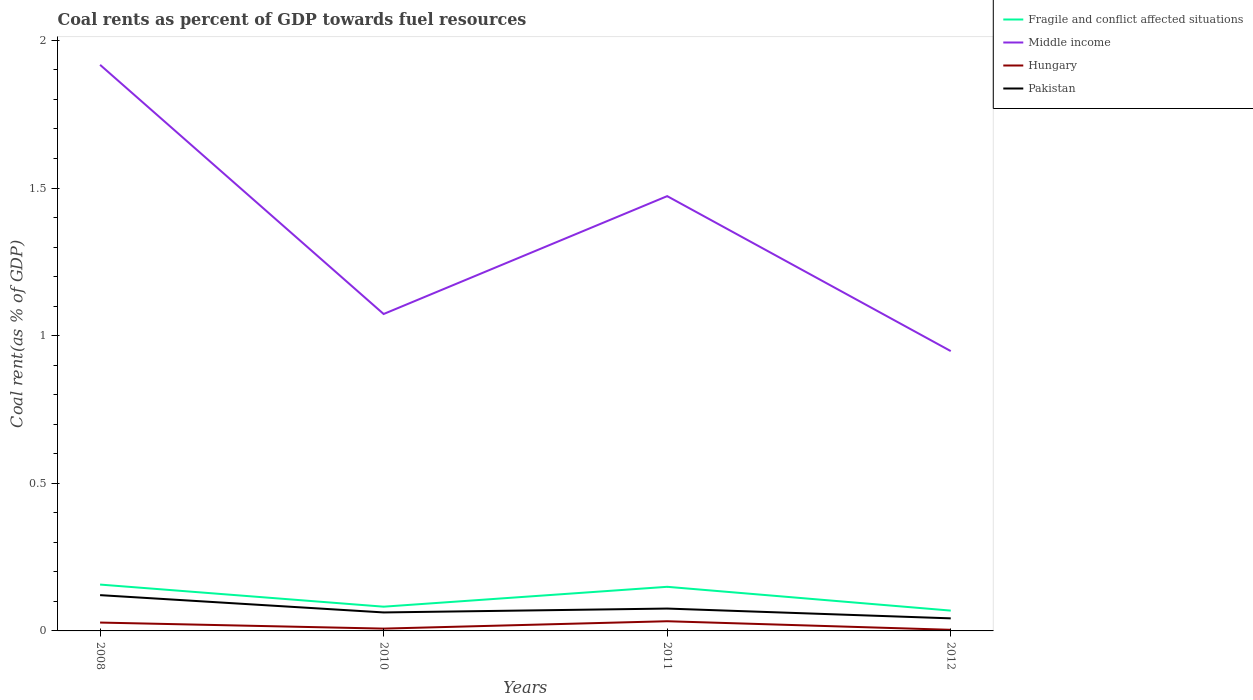How many different coloured lines are there?
Make the answer very short. 4. Does the line corresponding to Middle income intersect with the line corresponding to Pakistan?
Give a very brief answer. No. Is the number of lines equal to the number of legend labels?
Offer a very short reply. Yes. Across all years, what is the maximum coal rent in Middle income?
Offer a very short reply. 0.95. What is the total coal rent in Pakistan in the graph?
Keep it short and to the point. 0.02. What is the difference between the highest and the second highest coal rent in Middle income?
Provide a short and direct response. 0.97. Is the coal rent in Hungary strictly greater than the coal rent in Middle income over the years?
Provide a succinct answer. Yes. How many lines are there?
Keep it short and to the point. 4. Are the values on the major ticks of Y-axis written in scientific E-notation?
Your answer should be very brief. No. Does the graph contain any zero values?
Your response must be concise. No. Where does the legend appear in the graph?
Ensure brevity in your answer.  Top right. How are the legend labels stacked?
Ensure brevity in your answer.  Vertical. What is the title of the graph?
Your answer should be very brief. Coal rents as percent of GDP towards fuel resources. What is the label or title of the X-axis?
Your answer should be very brief. Years. What is the label or title of the Y-axis?
Ensure brevity in your answer.  Coal rent(as % of GDP). What is the Coal rent(as % of GDP) in Fragile and conflict affected situations in 2008?
Keep it short and to the point. 0.16. What is the Coal rent(as % of GDP) in Middle income in 2008?
Make the answer very short. 1.92. What is the Coal rent(as % of GDP) of Hungary in 2008?
Your response must be concise. 0.03. What is the Coal rent(as % of GDP) in Pakistan in 2008?
Give a very brief answer. 0.12. What is the Coal rent(as % of GDP) in Fragile and conflict affected situations in 2010?
Keep it short and to the point. 0.08. What is the Coal rent(as % of GDP) in Middle income in 2010?
Make the answer very short. 1.07. What is the Coal rent(as % of GDP) of Hungary in 2010?
Ensure brevity in your answer.  0.01. What is the Coal rent(as % of GDP) of Pakistan in 2010?
Your response must be concise. 0.06. What is the Coal rent(as % of GDP) of Fragile and conflict affected situations in 2011?
Ensure brevity in your answer.  0.15. What is the Coal rent(as % of GDP) in Middle income in 2011?
Offer a terse response. 1.47. What is the Coal rent(as % of GDP) in Hungary in 2011?
Make the answer very short. 0.03. What is the Coal rent(as % of GDP) of Pakistan in 2011?
Offer a very short reply. 0.08. What is the Coal rent(as % of GDP) in Fragile and conflict affected situations in 2012?
Provide a succinct answer. 0.07. What is the Coal rent(as % of GDP) in Middle income in 2012?
Offer a very short reply. 0.95. What is the Coal rent(as % of GDP) in Hungary in 2012?
Give a very brief answer. 0. What is the Coal rent(as % of GDP) in Pakistan in 2012?
Make the answer very short. 0.04. Across all years, what is the maximum Coal rent(as % of GDP) in Fragile and conflict affected situations?
Your answer should be compact. 0.16. Across all years, what is the maximum Coal rent(as % of GDP) in Middle income?
Your answer should be compact. 1.92. Across all years, what is the maximum Coal rent(as % of GDP) of Hungary?
Offer a terse response. 0.03. Across all years, what is the maximum Coal rent(as % of GDP) in Pakistan?
Offer a terse response. 0.12. Across all years, what is the minimum Coal rent(as % of GDP) of Fragile and conflict affected situations?
Provide a succinct answer. 0.07. Across all years, what is the minimum Coal rent(as % of GDP) of Middle income?
Your answer should be very brief. 0.95. Across all years, what is the minimum Coal rent(as % of GDP) of Hungary?
Provide a succinct answer. 0. Across all years, what is the minimum Coal rent(as % of GDP) of Pakistan?
Provide a succinct answer. 0.04. What is the total Coal rent(as % of GDP) of Fragile and conflict affected situations in the graph?
Provide a short and direct response. 0.46. What is the total Coal rent(as % of GDP) of Middle income in the graph?
Your response must be concise. 5.41. What is the total Coal rent(as % of GDP) of Hungary in the graph?
Offer a terse response. 0.07. What is the total Coal rent(as % of GDP) of Pakistan in the graph?
Make the answer very short. 0.3. What is the difference between the Coal rent(as % of GDP) in Fragile and conflict affected situations in 2008 and that in 2010?
Make the answer very short. 0.07. What is the difference between the Coal rent(as % of GDP) of Middle income in 2008 and that in 2010?
Provide a succinct answer. 0.84. What is the difference between the Coal rent(as % of GDP) of Hungary in 2008 and that in 2010?
Your answer should be compact. 0.02. What is the difference between the Coal rent(as % of GDP) in Pakistan in 2008 and that in 2010?
Your answer should be very brief. 0.06. What is the difference between the Coal rent(as % of GDP) in Fragile and conflict affected situations in 2008 and that in 2011?
Offer a terse response. 0.01. What is the difference between the Coal rent(as % of GDP) of Middle income in 2008 and that in 2011?
Provide a succinct answer. 0.44. What is the difference between the Coal rent(as % of GDP) of Hungary in 2008 and that in 2011?
Your answer should be very brief. -0. What is the difference between the Coal rent(as % of GDP) of Pakistan in 2008 and that in 2011?
Provide a short and direct response. 0.05. What is the difference between the Coal rent(as % of GDP) in Fragile and conflict affected situations in 2008 and that in 2012?
Keep it short and to the point. 0.09. What is the difference between the Coal rent(as % of GDP) of Middle income in 2008 and that in 2012?
Make the answer very short. 0.97. What is the difference between the Coal rent(as % of GDP) in Hungary in 2008 and that in 2012?
Keep it short and to the point. 0.02. What is the difference between the Coal rent(as % of GDP) of Pakistan in 2008 and that in 2012?
Give a very brief answer. 0.08. What is the difference between the Coal rent(as % of GDP) of Fragile and conflict affected situations in 2010 and that in 2011?
Your answer should be very brief. -0.07. What is the difference between the Coal rent(as % of GDP) of Middle income in 2010 and that in 2011?
Your response must be concise. -0.4. What is the difference between the Coal rent(as % of GDP) of Hungary in 2010 and that in 2011?
Offer a terse response. -0.03. What is the difference between the Coal rent(as % of GDP) in Pakistan in 2010 and that in 2011?
Your answer should be very brief. -0.01. What is the difference between the Coal rent(as % of GDP) in Fragile and conflict affected situations in 2010 and that in 2012?
Keep it short and to the point. 0.01. What is the difference between the Coal rent(as % of GDP) of Middle income in 2010 and that in 2012?
Your answer should be compact. 0.13. What is the difference between the Coal rent(as % of GDP) of Hungary in 2010 and that in 2012?
Offer a very short reply. 0. What is the difference between the Coal rent(as % of GDP) in Fragile and conflict affected situations in 2011 and that in 2012?
Keep it short and to the point. 0.08. What is the difference between the Coal rent(as % of GDP) in Middle income in 2011 and that in 2012?
Your response must be concise. 0.52. What is the difference between the Coal rent(as % of GDP) of Hungary in 2011 and that in 2012?
Your answer should be compact. 0.03. What is the difference between the Coal rent(as % of GDP) of Pakistan in 2011 and that in 2012?
Offer a terse response. 0.03. What is the difference between the Coal rent(as % of GDP) in Fragile and conflict affected situations in 2008 and the Coal rent(as % of GDP) in Middle income in 2010?
Offer a very short reply. -0.92. What is the difference between the Coal rent(as % of GDP) of Fragile and conflict affected situations in 2008 and the Coal rent(as % of GDP) of Hungary in 2010?
Keep it short and to the point. 0.15. What is the difference between the Coal rent(as % of GDP) in Fragile and conflict affected situations in 2008 and the Coal rent(as % of GDP) in Pakistan in 2010?
Your answer should be compact. 0.09. What is the difference between the Coal rent(as % of GDP) in Middle income in 2008 and the Coal rent(as % of GDP) in Hungary in 2010?
Offer a terse response. 1.91. What is the difference between the Coal rent(as % of GDP) of Middle income in 2008 and the Coal rent(as % of GDP) of Pakistan in 2010?
Make the answer very short. 1.85. What is the difference between the Coal rent(as % of GDP) of Hungary in 2008 and the Coal rent(as % of GDP) of Pakistan in 2010?
Provide a short and direct response. -0.03. What is the difference between the Coal rent(as % of GDP) of Fragile and conflict affected situations in 2008 and the Coal rent(as % of GDP) of Middle income in 2011?
Offer a terse response. -1.32. What is the difference between the Coal rent(as % of GDP) in Fragile and conflict affected situations in 2008 and the Coal rent(as % of GDP) in Hungary in 2011?
Offer a very short reply. 0.12. What is the difference between the Coal rent(as % of GDP) of Fragile and conflict affected situations in 2008 and the Coal rent(as % of GDP) of Pakistan in 2011?
Ensure brevity in your answer.  0.08. What is the difference between the Coal rent(as % of GDP) of Middle income in 2008 and the Coal rent(as % of GDP) of Hungary in 2011?
Your answer should be compact. 1.88. What is the difference between the Coal rent(as % of GDP) in Middle income in 2008 and the Coal rent(as % of GDP) in Pakistan in 2011?
Give a very brief answer. 1.84. What is the difference between the Coal rent(as % of GDP) of Hungary in 2008 and the Coal rent(as % of GDP) of Pakistan in 2011?
Offer a terse response. -0.05. What is the difference between the Coal rent(as % of GDP) of Fragile and conflict affected situations in 2008 and the Coal rent(as % of GDP) of Middle income in 2012?
Offer a terse response. -0.79. What is the difference between the Coal rent(as % of GDP) of Fragile and conflict affected situations in 2008 and the Coal rent(as % of GDP) of Hungary in 2012?
Ensure brevity in your answer.  0.15. What is the difference between the Coal rent(as % of GDP) of Fragile and conflict affected situations in 2008 and the Coal rent(as % of GDP) of Pakistan in 2012?
Your answer should be compact. 0.11. What is the difference between the Coal rent(as % of GDP) of Middle income in 2008 and the Coal rent(as % of GDP) of Hungary in 2012?
Your response must be concise. 1.91. What is the difference between the Coal rent(as % of GDP) of Middle income in 2008 and the Coal rent(as % of GDP) of Pakistan in 2012?
Provide a succinct answer. 1.87. What is the difference between the Coal rent(as % of GDP) in Hungary in 2008 and the Coal rent(as % of GDP) in Pakistan in 2012?
Give a very brief answer. -0.01. What is the difference between the Coal rent(as % of GDP) of Fragile and conflict affected situations in 2010 and the Coal rent(as % of GDP) of Middle income in 2011?
Offer a very short reply. -1.39. What is the difference between the Coal rent(as % of GDP) of Fragile and conflict affected situations in 2010 and the Coal rent(as % of GDP) of Hungary in 2011?
Offer a terse response. 0.05. What is the difference between the Coal rent(as % of GDP) of Fragile and conflict affected situations in 2010 and the Coal rent(as % of GDP) of Pakistan in 2011?
Offer a very short reply. 0.01. What is the difference between the Coal rent(as % of GDP) of Middle income in 2010 and the Coal rent(as % of GDP) of Hungary in 2011?
Offer a very short reply. 1.04. What is the difference between the Coal rent(as % of GDP) of Hungary in 2010 and the Coal rent(as % of GDP) of Pakistan in 2011?
Provide a short and direct response. -0.07. What is the difference between the Coal rent(as % of GDP) of Fragile and conflict affected situations in 2010 and the Coal rent(as % of GDP) of Middle income in 2012?
Provide a short and direct response. -0.87. What is the difference between the Coal rent(as % of GDP) of Fragile and conflict affected situations in 2010 and the Coal rent(as % of GDP) of Hungary in 2012?
Your response must be concise. 0.08. What is the difference between the Coal rent(as % of GDP) of Fragile and conflict affected situations in 2010 and the Coal rent(as % of GDP) of Pakistan in 2012?
Give a very brief answer. 0.04. What is the difference between the Coal rent(as % of GDP) in Middle income in 2010 and the Coal rent(as % of GDP) in Hungary in 2012?
Ensure brevity in your answer.  1.07. What is the difference between the Coal rent(as % of GDP) in Middle income in 2010 and the Coal rent(as % of GDP) in Pakistan in 2012?
Give a very brief answer. 1.03. What is the difference between the Coal rent(as % of GDP) in Hungary in 2010 and the Coal rent(as % of GDP) in Pakistan in 2012?
Provide a succinct answer. -0.03. What is the difference between the Coal rent(as % of GDP) of Fragile and conflict affected situations in 2011 and the Coal rent(as % of GDP) of Middle income in 2012?
Your answer should be very brief. -0.8. What is the difference between the Coal rent(as % of GDP) in Fragile and conflict affected situations in 2011 and the Coal rent(as % of GDP) in Hungary in 2012?
Provide a short and direct response. 0.15. What is the difference between the Coal rent(as % of GDP) in Fragile and conflict affected situations in 2011 and the Coal rent(as % of GDP) in Pakistan in 2012?
Provide a short and direct response. 0.11. What is the difference between the Coal rent(as % of GDP) in Middle income in 2011 and the Coal rent(as % of GDP) in Hungary in 2012?
Offer a very short reply. 1.47. What is the difference between the Coal rent(as % of GDP) in Middle income in 2011 and the Coal rent(as % of GDP) in Pakistan in 2012?
Your response must be concise. 1.43. What is the difference between the Coal rent(as % of GDP) of Hungary in 2011 and the Coal rent(as % of GDP) of Pakistan in 2012?
Keep it short and to the point. -0.01. What is the average Coal rent(as % of GDP) of Fragile and conflict affected situations per year?
Give a very brief answer. 0.11. What is the average Coal rent(as % of GDP) of Middle income per year?
Your answer should be very brief. 1.35. What is the average Coal rent(as % of GDP) of Hungary per year?
Ensure brevity in your answer.  0.02. What is the average Coal rent(as % of GDP) in Pakistan per year?
Provide a short and direct response. 0.08. In the year 2008, what is the difference between the Coal rent(as % of GDP) of Fragile and conflict affected situations and Coal rent(as % of GDP) of Middle income?
Provide a succinct answer. -1.76. In the year 2008, what is the difference between the Coal rent(as % of GDP) of Fragile and conflict affected situations and Coal rent(as % of GDP) of Hungary?
Offer a very short reply. 0.13. In the year 2008, what is the difference between the Coal rent(as % of GDP) of Fragile and conflict affected situations and Coal rent(as % of GDP) of Pakistan?
Offer a very short reply. 0.04. In the year 2008, what is the difference between the Coal rent(as % of GDP) of Middle income and Coal rent(as % of GDP) of Hungary?
Your response must be concise. 1.89. In the year 2008, what is the difference between the Coal rent(as % of GDP) of Middle income and Coal rent(as % of GDP) of Pakistan?
Provide a short and direct response. 1.8. In the year 2008, what is the difference between the Coal rent(as % of GDP) in Hungary and Coal rent(as % of GDP) in Pakistan?
Give a very brief answer. -0.09. In the year 2010, what is the difference between the Coal rent(as % of GDP) in Fragile and conflict affected situations and Coal rent(as % of GDP) in Middle income?
Give a very brief answer. -0.99. In the year 2010, what is the difference between the Coal rent(as % of GDP) of Fragile and conflict affected situations and Coal rent(as % of GDP) of Hungary?
Make the answer very short. 0.07. In the year 2010, what is the difference between the Coal rent(as % of GDP) of Fragile and conflict affected situations and Coal rent(as % of GDP) of Pakistan?
Ensure brevity in your answer.  0.02. In the year 2010, what is the difference between the Coal rent(as % of GDP) in Middle income and Coal rent(as % of GDP) in Hungary?
Offer a very short reply. 1.07. In the year 2010, what is the difference between the Coal rent(as % of GDP) in Middle income and Coal rent(as % of GDP) in Pakistan?
Offer a terse response. 1.01. In the year 2010, what is the difference between the Coal rent(as % of GDP) in Hungary and Coal rent(as % of GDP) in Pakistan?
Offer a very short reply. -0.05. In the year 2011, what is the difference between the Coal rent(as % of GDP) in Fragile and conflict affected situations and Coal rent(as % of GDP) in Middle income?
Ensure brevity in your answer.  -1.32. In the year 2011, what is the difference between the Coal rent(as % of GDP) of Fragile and conflict affected situations and Coal rent(as % of GDP) of Hungary?
Your answer should be compact. 0.12. In the year 2011, what is the difference between the Coal rent(as % of GDP) of Fragile and conflict affected situations and Coal rent(as % of GDP) of Pakistan?
Ensure brevity in your answer.  0.07. In the year 2011, what is the difference between the Coal rent(as % of GDP) in Middle income and Coal rent(as % of GDP) in Hungary?
Your response must be concise. 1.44. In the year 2011, what is the difference between the Coal rent(as % of GDP) in Middle income and Coal rent(as % of GDP) in Pakistan?
Make the answer very short. 1.4. In the year 2011, what is the difference between the Coal rent(as % of GDP) in Hungary and Coal rent(as % of GDP) in Pakistan?
Your answer should be very brief. -0.04. In the year 2012, what is the difference between the Coal rent(as % of GDP) in Fragile and conflict affected situations and Coal rent(as % of GDP) in Middle income?
Your response must be concise. -0.88. In the year 2012, what is the difference between the Coal rent(as % of GDP) in Fragile and conflict affected situations and Coal rent(as % of GDP) in Hungary?
Provide a succinct answer. 0.07. In the year 2012, what is the difference between the Coal rent(as % of GDP) in Fragile and conflict affected situations and Coal rent(as % of GDP) in Pakistan?
Your response must be concise. 0.03. In the year 2012, what is the difference between the Coal rent(as % of GDP) in Middle income and Coal rent(as % of GDP) in Hungary?
Provide a succinct answer. 0.94. In the year 2012, what is the difference between the Coal rent(as % of GDP) of Middle income and Coal rent(as % of GDP) of Pakistan?
Your answer should be compact. 0.91. In the year 2012, what is the difference between the Coal rent(as % of GDP) of Hungary and Coal rent(as % of GDP) of Pakistan?
Make the answer very short. -0.04. What is the ratio of the Coal rent(as % of GDP) in Fragile and conflict affected situations in 2008 to that in 2010?
Keep it short and to the point. 1.91. What is the ratio of the Coal rent(as % of GDP) in Middle income in 2008 to that in 2010?
Offer a terse response. 1.79. What is the ratio of the Coal rent(as % of GDP) of Hungary in 2008 to that in 2010?
Provide a succinct answer. 3.61. What is the ratio of the Coal rent(as % of GDP) in Pakistan in 2008 to that in 2010?
Your answer should be very brief. 1.94. What is the ratio of the Coal rent(as % of GDP) of Fragile and conflict affected situations in 2008 to that in 2011?
Your answer should be compact. 1.05. What is the ratio of the Coal rent(as % of GDP) of Middle income in 2008 to that in 2011?
Your response must be concise. 1.3. What is the ratio of the Coal rent(as % of GDP) of Hungary in 2008 to that in 2011?
Your answer should be very brief. 0.86. What is the ratio of the Coal rent(as % of GDP) of Pakistan in 2008 to that in 2011?
Provide a short and direct response. 1.6. What is the ratio of the Coal rent(as % of GDP) of Fragile and conflict affected situations in 2008 to that in 2012?
Ensure brevity in your answer.  2.28. What is the ratio of the Coal rent(as % of GDP) of Middle income in 2008 to that in 2012?
Your answer should be compact. 2.02. What is the ratio of the Coal rent(as % of GDP) in Hungary in 2008 to that in 2012?
Provide a succinct answer. 7.53. What is the ratio of the Coal rent(as % of GDP) in Pakistan in 2008 to that in 2012?
Offer a terse response. 2.85. What is the ratio of the Coal rent(as % of GDP) of Fragile and conflict affected situations in 2010 to that in 2011?
Provide a short and direct response. 0.55. What is the ratio of the Coal rent(as % of GDP) of Middle income in 2010 to that in 2011?
Provide a short and direct response. 0.73. What is the ratio of the Coal rent(as % of GDP) in Hungary in 2010 to that in 2011?
Ensure brevity in your answer.  0.24. What is the ratio of the Coal rent(as % of GDP) in Pakistan in 2010 to that in 2011?
Provide a short and direct response. 0.83. What is the ratio of the Coal rent(as % of GDP) in Fragile and conflict affected situations in 2010 to that in 2012?
Provide a succinct answer. 1.19. What is the ratio of the Coal rent(as % of GDP) in Middle income in 2010 to that in 2012?
Keep it short and to the point. 1.13. What is the ratio of the Coal rent(as % of GDP) of Hungary in 2010 to that in 2012?
Ensure brevity in your answer.  2.08. What is the ratio of the Coal rent(as % of GDP) of Pakistan in 2010 to that in 2012?
Offer a terse response. 1.47. What is the ratio of the Coal rent(as % of GDP) of Fragile and conflict affected situations in 2011 to that in 2012?
Offer a terse response. 2.17. What is the ratio of the Coal rent(as % of GDP) in Middle income in 2011 to that in 2012?
Your answer should be very brief. 1.55. What is the ratio of the Coal rent(as % of GDP) in Hungary in 2011 to that in 2012?
Offer a very short reply. 8.72. What is the ratio of the Coal rent(as % of GDP) in Pakistan in 2011 to that in 2012?
Make the answer very short. 1.78. What is the difference between the highest and the second highest Coal rent(as % of GDP) of Fragile and conflict affected situations?
Your response must be concise. 0.01. What is the difference between the highest and the second highest Coal rent(as % of GDP) in Middle income?
Your answer should be compact. 0.44. What is the difference between the highest and the second highest Coal rent(as % of GDP) of Hungary?
Your response must be concise. 0. What is the difference between the highest and the second highest Coal rent(as % of GDP) of Pakistan?
Your answer should be compact. 0.05. What is the difference between the highest and the lowest Coal rent(as % of GDP) of Fragile and conflict affected situations?
Offer a very short reply. 0.09. What is the difference between the highest and the lowest Coal rent(as % of GDP) of Middle income?
Your response must be concise. 0.97. What is the difference between the highest and the lowest Coal rent(as % of GDP) in Hungary?
Provide a succinct answer. 0.03. What is the difference between the highest and the lowest Coal rent(as % of GDP) in Pakistan?
Ensure brevity in your answer.  0.08. 